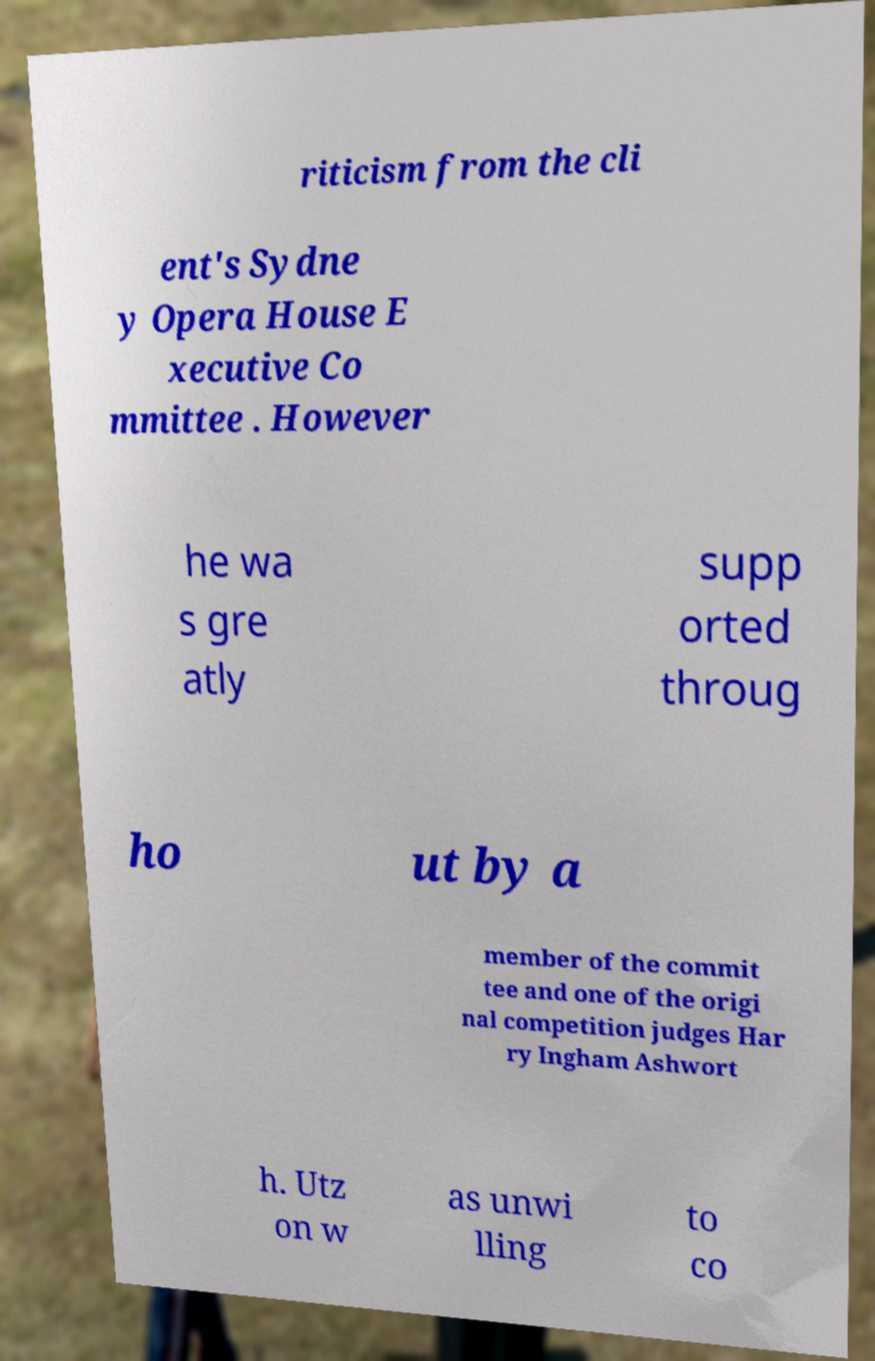For documentation purposes, I need the text within this image transcribed. Could you provide that? riticism from the cli ent's Sydne y Opera House E xecutive Co mmittee . However he wa s gre atly supp orted throug ho ut by a member of the commit tee and one of the origi nal competition judges Har ry Ingham Ashwort h. Utz on w as unwi lling to co 